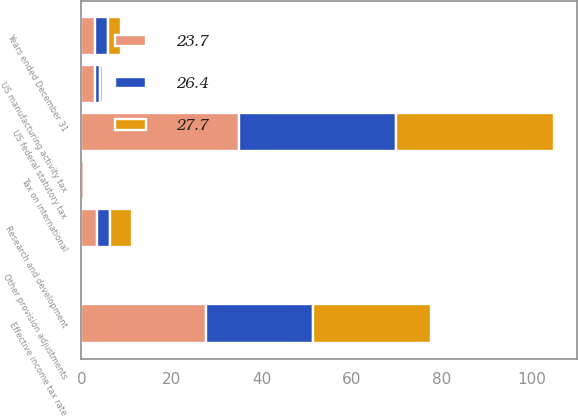Convert chart. <chart><loc_0><loc_0><loc_500><loc_500><stacked_bar_chart><ecel><fcel>Years ended December 31<fcel>US federal statutory tax<fcel>Research and development<fcel>US manufacturing activity tax<fcel>Tax on international<fcel>Other provision adjustments<fcel>Effective income tax rate<nl><fcel>23.7<fcel>2.9<fcel>35<fcel>3.4<fcel>2.9<fcel>0.6<fcel>0.4<fcel>27.7<nl><fcel>26.4<fcel>2.9<fcel>35<fcel>2.9<fcel>1.2<fcel>0.2<fcel>0.2<fcel>23.7<nl><fcel>27.7<fcel>2.9<fcel>35<fcel>4.9<fcel>0.6<fcel>0.1<fcel>0.4<fcel>26.4<nl></chart> 